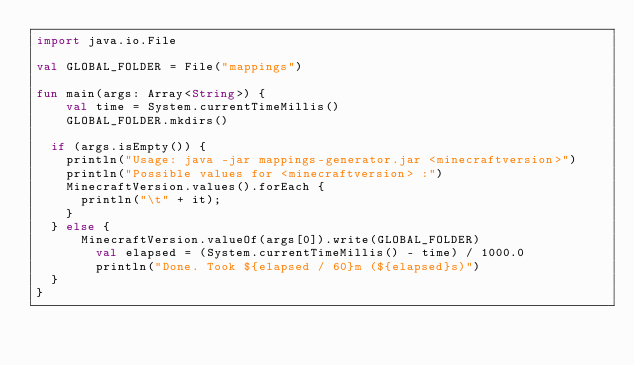Convert code to text. <code><loc_0><loc_0><loc_500><loc_500><_Kotlin_>import java.io.File

val GLOBAL_FOLDER = File("mappings")

fun main(args: Array<String>) {
    val time = System.currentTimeMillis()
    GLOBAL_FOLDER.mkdirs()

	if (args.isEmpty()) {
		println("Usage: java -jar mappings-generator.jar <minecraftversion>")
		println("Possible values for <minecraftversion> :")
		MinecraftVersion.values().forEach {
			println("\t" + it);
		}
	} else {
	    MinecraftVersion.valueOf(args[0]).write(GLOBAL_FOLDER)
        val elapsed = (System.currentTimeMillis() - time) / 1000.0
        println("Done. Took ${elapsed / 60}m (${elapsed}s)")
	}
}
</code> 